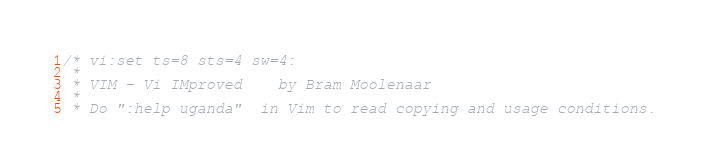Convert code to text. <code><loc_0><loc_0><loc_500><loc_500><_C_>/* vi:set ts=8 sts=4 sw=4:
 *
 * VIM - Vi IMproved	by Bram Moolenaar
 *
 * Do ":help uganda"  in Vim to read copying and usage conditions.</code> 